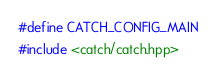Convert code to text. <code><loc_0><loc_0><loc_500><loc_500><_C++_>#define CATCH_CONFIG_MAIN
#include <catch/catch.hpp>

</code> 